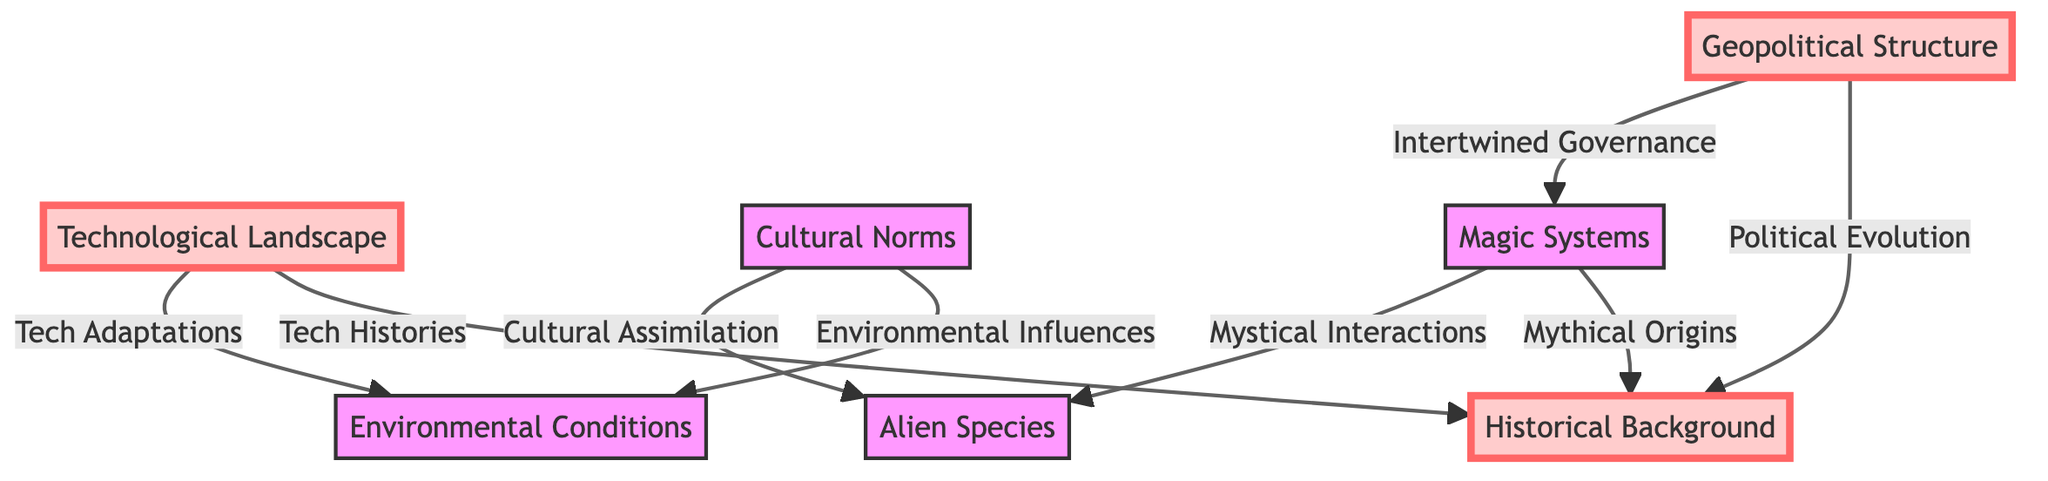What is the title of the first big node in the diagram? The first big node is labeled "Geopolitical Structure." Since big nodes are the primary categories in the diagram, they typically provide overarching themes. The topmost node, "Geopolitical Structure," fits this role.
Answer: Geopolitical Structure What is the relationship between the "Geopolitical Structure" and "Magic Systems"? The relationship is defined as "Intertwined Governance," illustrating how governance and magic systems are connected in the world-building process. The arrow indicates a direct correlation between these two aspects.
Answer: Intertwined Governance How many total nodes are there in the diagram? There are seven nodes in total. This includes both the big nodes and the smaller nodes. By counting each individual node shown in the diagram, we arrive at the total count.
Answer: 7 What are the two connections from "Technological Landscape"? The connections are "Tech Adaptations" and "Tech Histories." These two arrows originating from "Technological Landscape" indicate the specific ways technology interacts with other elements in the diagram.
Answer: Tech Adaptations, Tech Histories Which big node is connected to the "Historical Background" node? The "Geopolitical Structure" and "Technological Landscape" nodes are both connected to "Historical Background" through the relationships "Political Evolution" and "Tech Histories," respectively. The possible connections indicate that historical elements affect multiple world-building components.
Answer: Geopolitical Structure, Technological Landscape What influences "Cultural Norms" according to the diagram? "Cultural Norms" is influenced by "Cultural Assimilation" and "Environmental Influences." The arrows show how cultural aspects are intertwined with social and environmental factors in the narrative framework.
Answer: Cultural Assimilation, Environmental Influences What type of relationship does "Magic Systems" have with "Alien Species"? The relationship is called "Mystical Interactions," which suggests that there is a form of interaction or influence between these two concepts in the context of the world being built. The arrow indicates a direct link between them.
Answer: Mystical Interactions Which big node has the most connections in the diagram? The "Historical Background" big node has the most connections, with arrows pointing towards it from both "Geopolitical Structure" and "Technological Landscape," as well as its relationship with "Magic Systems." This indicates that historical context is foundational to several elements.
Answer: Historical Background What defines the connection between "Cultural Norms" and "Alien Species"? The defining connection is "Cultural Assimilation." This indicates that the incorporation of alien cultures impacts the societal norms of the world, reflected as a direct relationship in the diagram.
Answer: Cultural Assimilation 